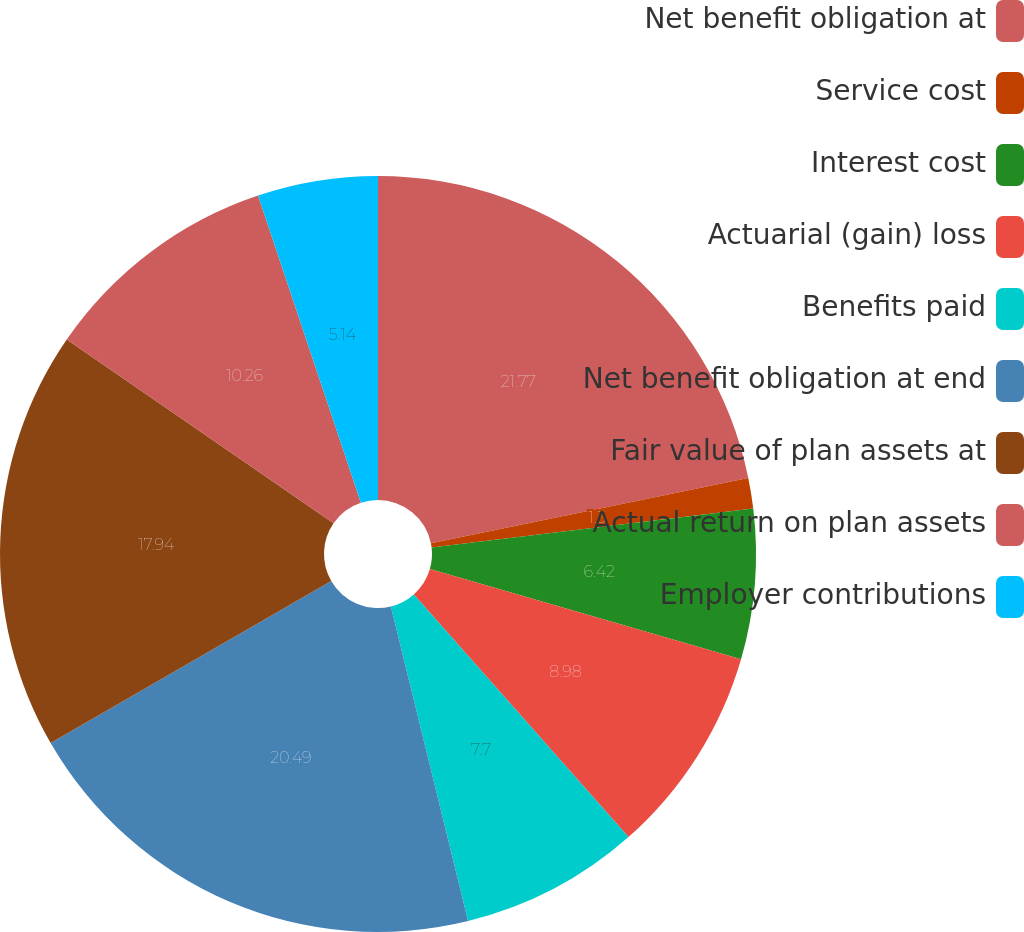Convert chart. <chart><loc_0><loc_0><loc_500><loc_500><pie_chart><fcel>Net benefit obligation at<fcel>Service cost<fcel>Interest cost<fcel>Actuarial (gain) loss<fcel>Benefits paid<fcel>Net benefit obligation at end<fcel>Fair value of plan assets at<fcel>Actual return on plan assets<fcel>Employer contributions<nl><fcel>21.78%<fcel>1.3%<fcel>6.42%<fcel>8.98%<fcel>7.7%<fcel>20.5%<fcel>17.94%<fcel>10.26%<fcel>5.14%<nl></chart> 